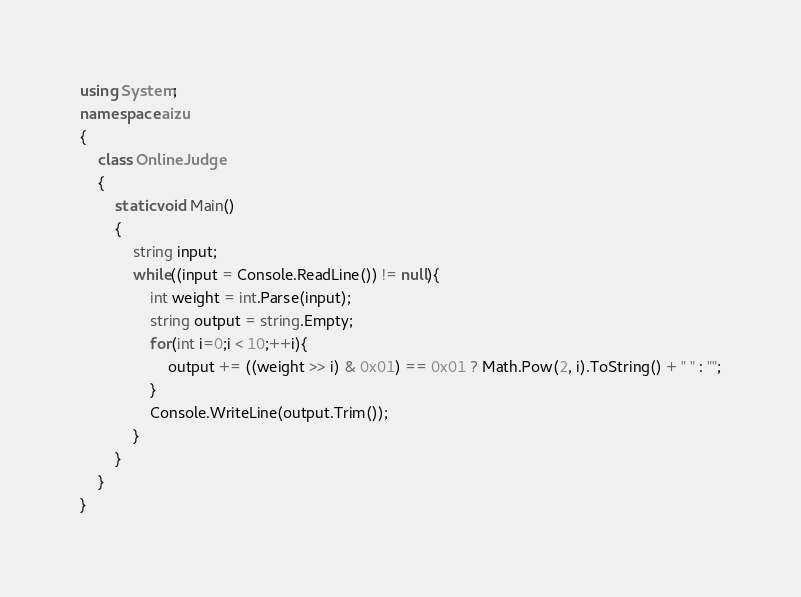Convert code to text. <code><loc_0><loc_0><loc_500><loc_500><_C#_>using System;
namespace aizu
{
    class OnlineJudge
    {
        static void Main()
        {
            string input;
            while((input = Console.ReadLine()) != null){
                int weight = int.Parse(input);
                string output = string.Empty;
                for(int i=0;i < 10;++i){
                    output += ((weight >> i) & 0x01) == 0x01 ? Math.Pow(2, i).ToString() + " " : "";
                }
                Console.WriteLine(output.Trim());
            }
        }
    }
}</code> 